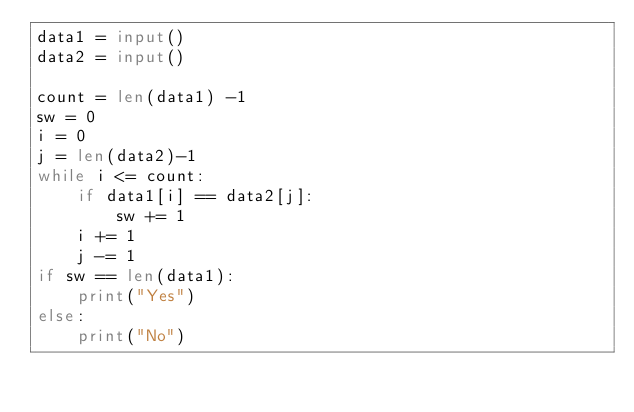Convert code to text. <code><loc_0><loc_0><loc_500><loc_500><_Python_>data1 = input()
data2 = input()

count = len(data1) -1
sw = 0
i = 0
j = len(data2)-1
while i <= count:
    if data1[i] == data2[j]:
        sw += 1
    i += 1
    j -= 1
if sw == len(data1):
    print("Yes")
else:
    print("No")</code> 